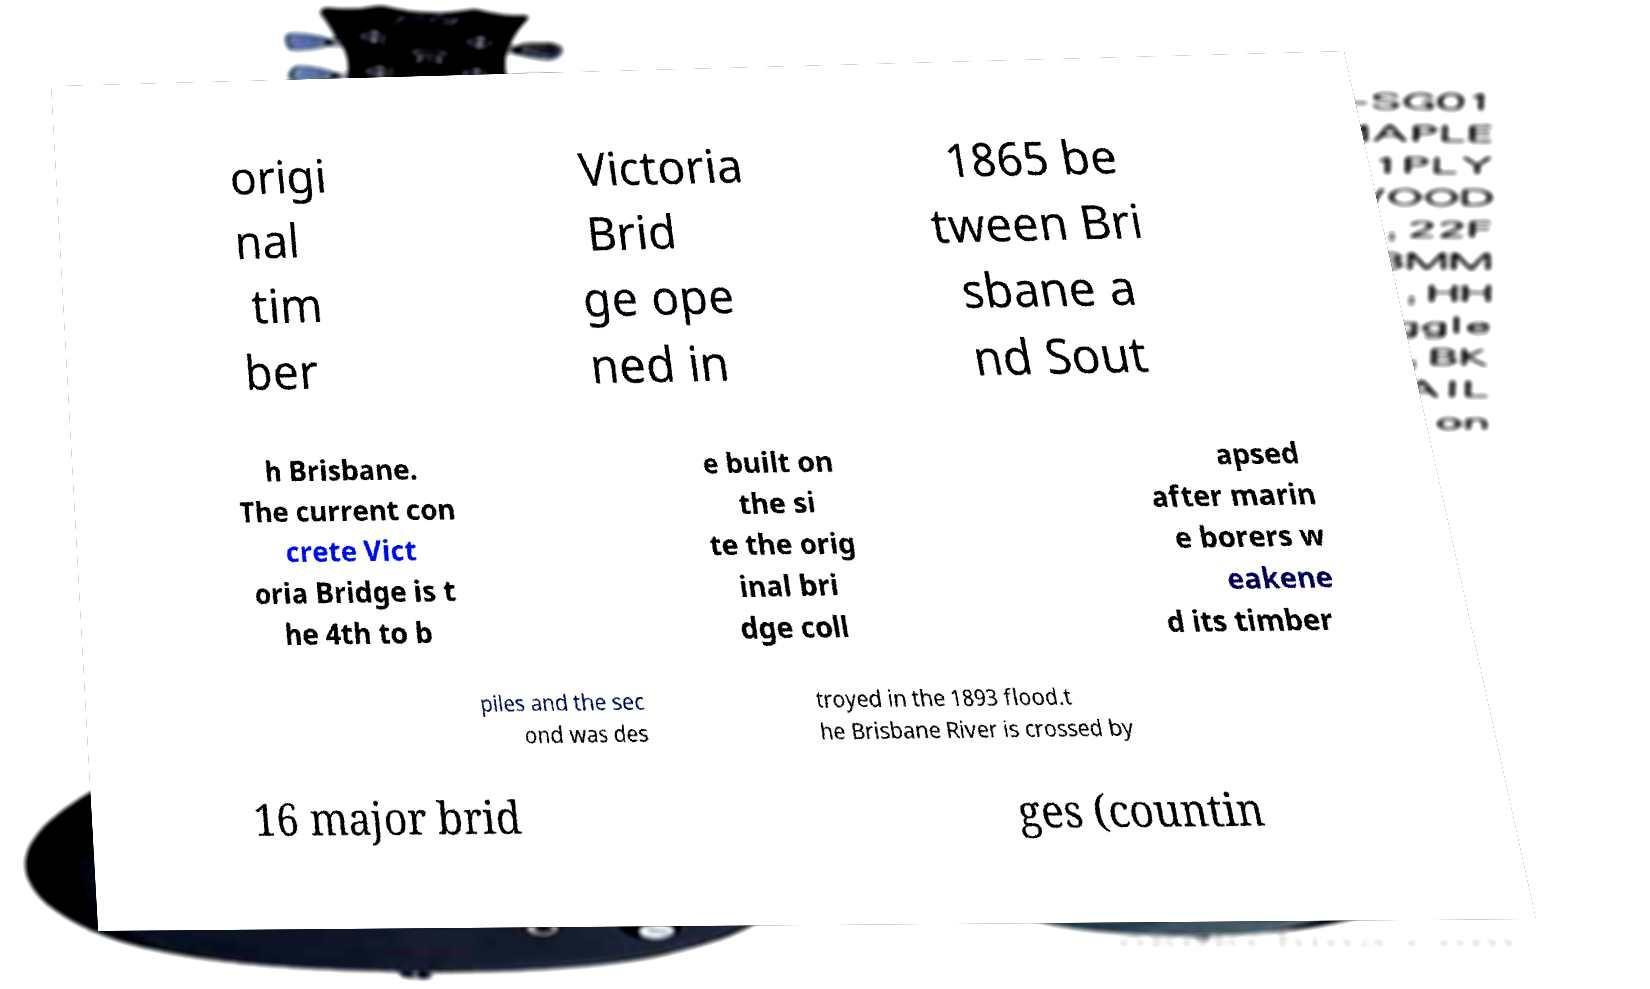Please identify and transcribe the text found in this image. origi nal tim ber Victoria Brid ge ope ned in 1865 be tween Bri sbane a nd Sout h Brisbane. The current con crete Vict oria Bridge is t he 4th to b e built on the si te the orig inal bri dge coll apsed after marin e borers w eakene d its timber piles and the sec ond was des troyed in the 1893 flood.t he Brisbane River is crossed by 16 major brid ges (countin 